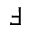Convert formula to latex. <formula><loc_0><loc_0><loc_500><loc_500>\Finv</formula> 